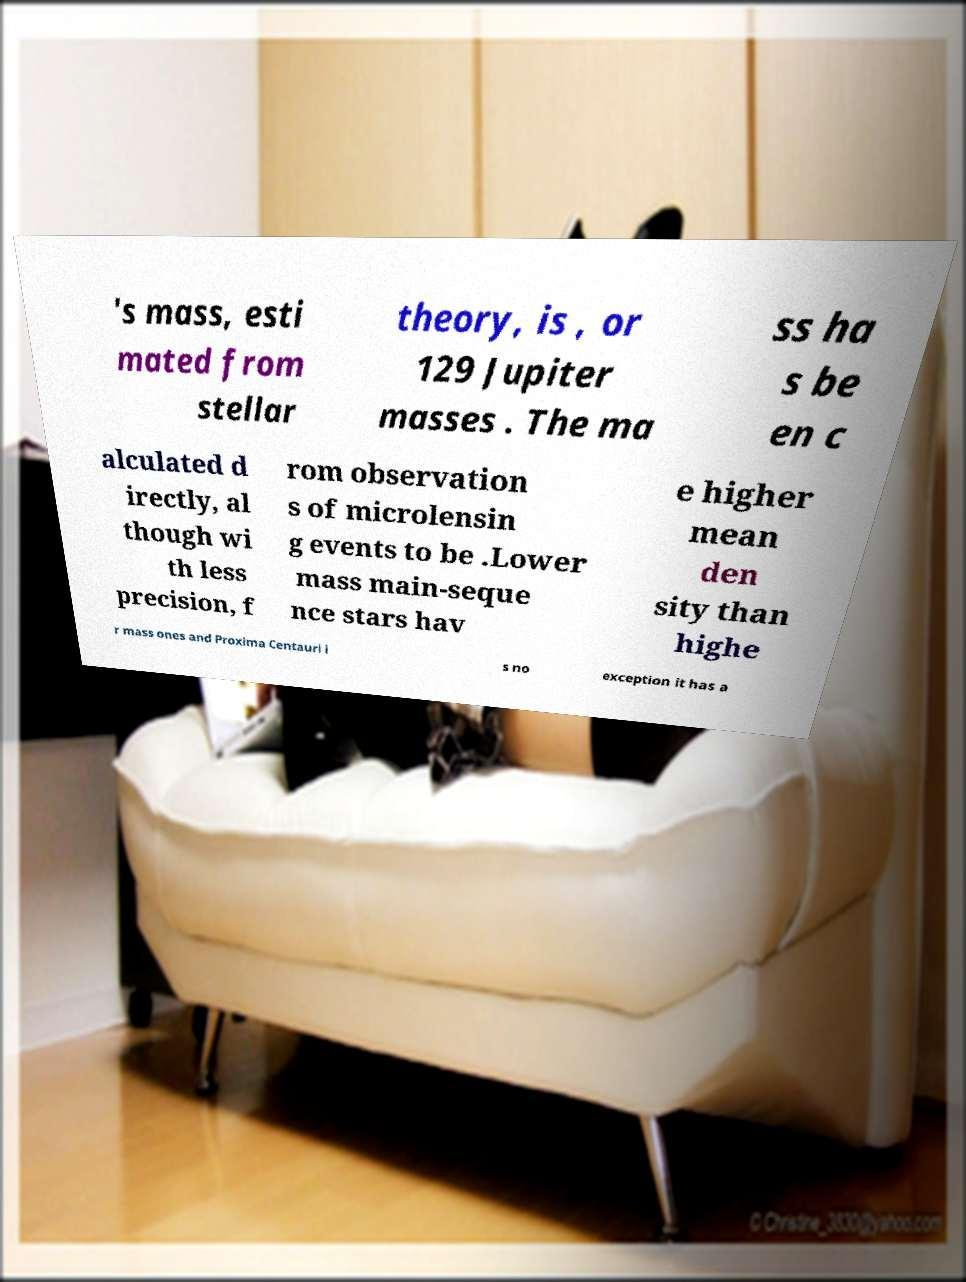Can you accurately transcribe the text from the provided image for me? 's mass, esti mated from stellar theory, is , or 129 Jupiter masses . The ma ss ha s be en c alculated d irectly, al though wi th less precision, f rom observation s of microlensin g events to be .Lower mass main-seque nce stars hav e higher mean den sity than highe r mass ones and Proxima Centauri i s no exception it has a 